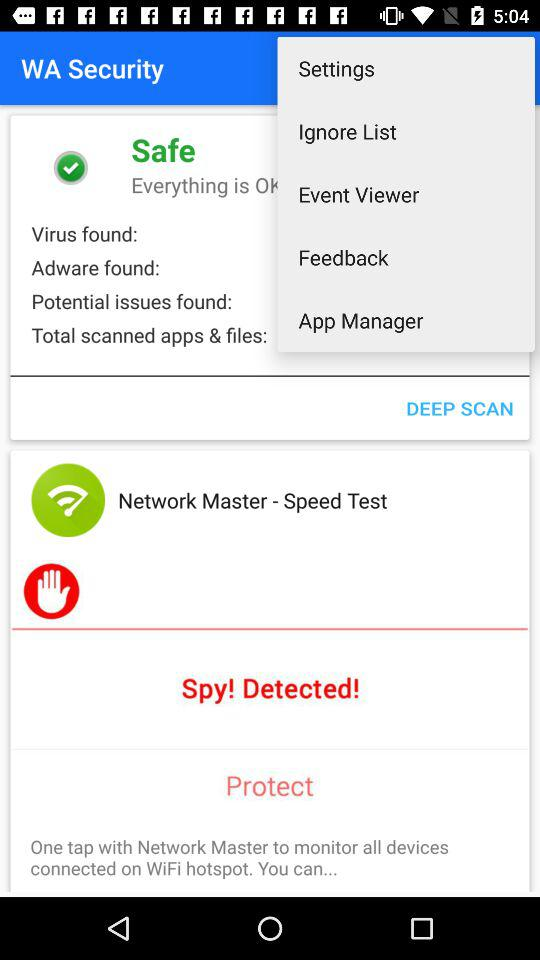What security has been successfully activated? The security that has been successfully activated is WA. 